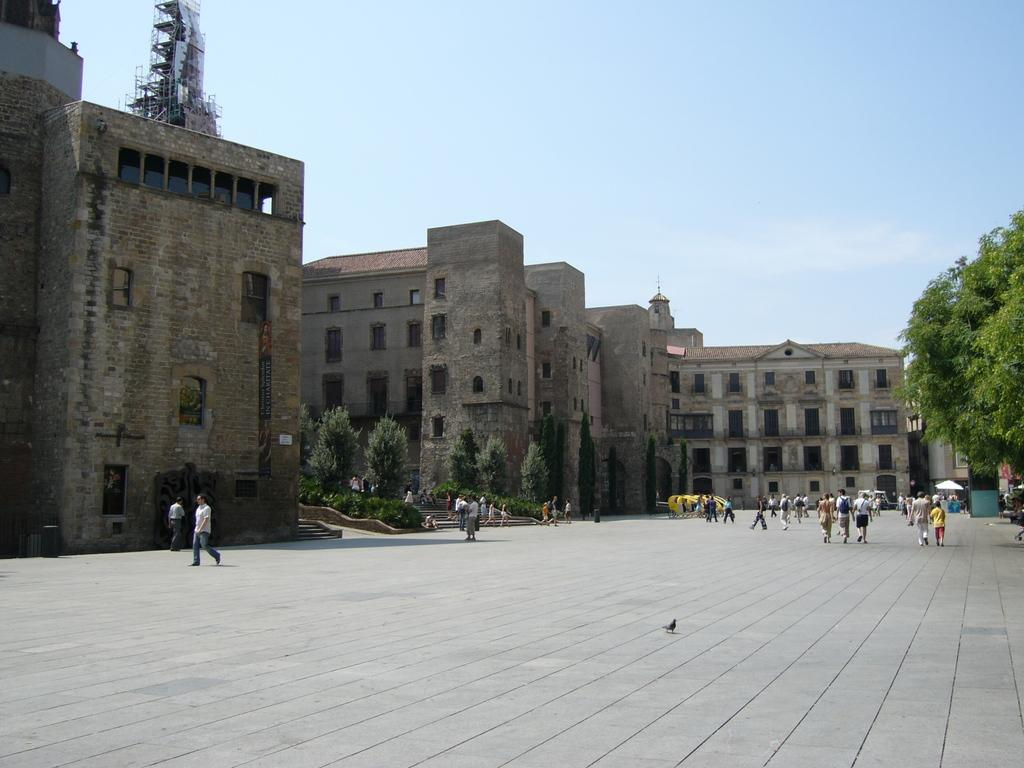What are the people in the image doing? The people in the image are walking on the land. What structures can be seen in the image? There are buildings in the image. What type of vegetation is on the right side of the image? There are trees on the right side of the image. What is visible in the background of the image? The sky is visible in the background of the image. What is the profit of the trees on the right side of the image? There is no mention of profit in the image, as it features people walking, buildings, trees, and the sky. What month is it in the image? The image does not provide any information about the month or time of year. 